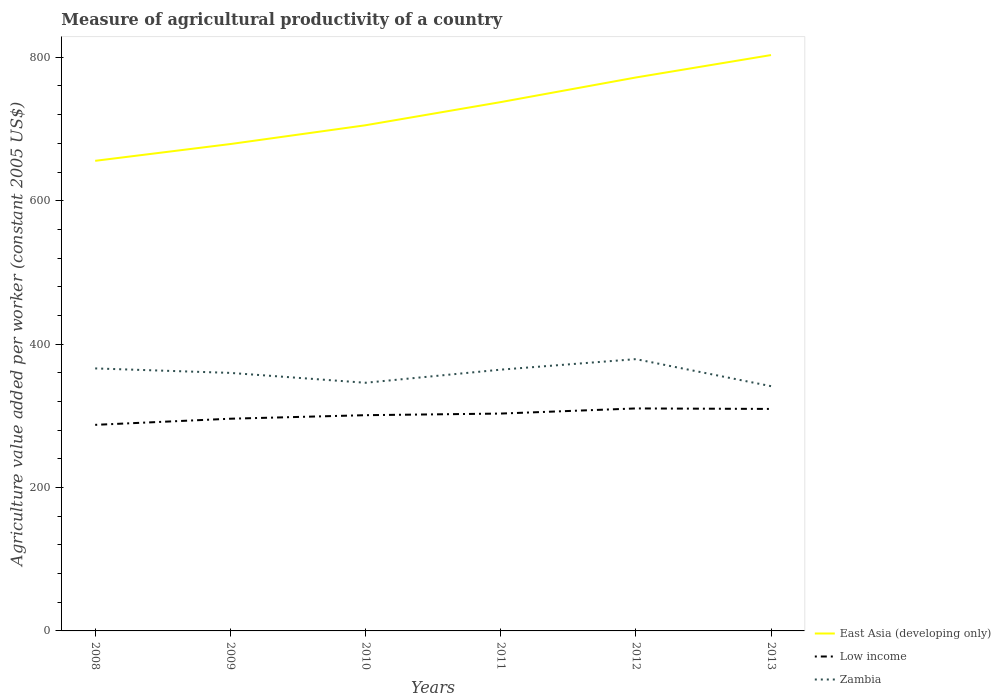How many different coloured lines are there?
Your answer should be very brief. 3. Across all years, what is the maximum measure of agricultural productivity in Low income?
Provide a short and direct response. 287.4. What is the total measure of agricultural productivity in East Asia (developing only) in the graph?
Your response must be concise. -92.83. What is the difference between the highest and the second highest measure of agricultural productivity in Low income?
Give a very brief answer. 22.89. Is the measure of agricultural productivity in Low income strictly greater than the measure of agricultural productivity in East Asia (developing only) over the years?
Provide a short and direct response. Yes. How many lines are there?
Keep it short and to the point. 3. Does the graph contain grids?
Provide a short and direct response. No. What is the title of the graph?
Ensure brevity in your answer.  Measure of agricultural productivity of a country. Does "North America" appear as one of the legend labels in the graph?
Provide a short and direct response. No. What is the label or title of the Y-axis?
Make the answer very short. Agriculture value added per worker (constant 2005 US$). What is the Agriculture value added per worker (constant 2005 US$) of East Asia (developing only) in 2008?
Your answer should be compact. 655.62. What is the Agriculture value added per worker (constant 2005 US$) of Low income in 2008?
Offer a terse response. 287.4. What is the Agriculture value added per worker (constant 2005 US$) of Zambia in 2008?
Give a very brief answer. 366.1. What is the Agriculture value added per worker (constant 2005 US$) in East Asia (developing only) in 2009?
Give a very brief answer. 679.02. What is the Agriculture value added per worker (constant 2005 US$) in Low income in 2009?
Offer a terse response. 295.95. What is the Agriculture value added per worker (constant 2005 US$) in Zambia in 2009?
Offer a terse response. 359.85. What is the Agriculture value added per worker (constant 2005 US$) of East Asia (developing only) in 2010?
Offer a very short reply. 705.23. What is the Agriculture value added per worker (constant 2005 US$) in Low income in 2010?
Make the answer very short. 300.88. What is the Agriculture value added per worker (constant 2005 US$) in Zambia in 2010?
Your answer should be very brief. 346.09. What is the Agriculture value added per worker (constant 2005 US$) of East Asia (developing only) in 2011?
Ensure brevity in your answer.  737.51. What is the Agriculture value added per worker (constant 2005 US$) of Low income in 2011?
Make the answer very short. 303.13. What is the Agriculture value added per worker (constant 2005 US$) in Zambia in 2011?
Your answer should be very brief. 364.38. What is the Agriculture value added per worker (constant 2005 US$) in East Asia (developing only) in 2012?
Ensure brevity in your answer.  771.85. What is the Agriculture value added per worker (constant 2005 US$) in Low income in 2012?
Your answer should be very brief. 310.29. What is the Agriculture value added per worker (constant 2005 US$) in Zambia in 2012?
Your response must be concise. 379.05. What is the Agriculture value added per worker (constant 2005 US$) in East Asia (developing only) in 2013?
Offer a terse response. 803.12. What is the Agriculture value added per worker (constant 2005 US$) of Low income in 2013?
Your answer should be very brief. 309.6. What is the Agriculture value added per worker (constant 2005 US$) of Zambia in 2013?
Your answer should be very brief. 341.34. Across all years, what is the maximum Agriculture value added per worker (constant 2005 US$) in East Asia (developing only)?
Your answer should be compact. 803.12. Across all years, what is the maximum Agriculture value added per worker (constant 2005 US$) of Low income?
Your answer should be very brief. 310.29. Across all years, what is the maximum Agriculture value added per worker (constant 2005 US$) of Zambia?
Your answer should be compact. 379.05. Across all years, what is the minimum Agriculture value added per worker (constant 2005 US$) in East Asia (developing only)?
Make the answer very short. 655.62. Across all years, what is the minimum Agriculture value added per worker (constant 2005 US$) of Low income?
Give a very brief answer. 287.4. Across all years, what is the minimum Agriculture value added per worker (constant 2005 US$) in Zambia?
Give a very brief answer. 341.34. What is the total Agriculture value added per worker (constant 2005 US$) of East Asia (developing only) in the graph?
Your response must be concise. 4352.35. What is the total Agriculture value added per worker (constant 2005 US$) of Low income in the graph?
Keep it short and to the point. 1807.24. What is the total Agriculture value added per worker (constant 2005 US$) of Zambia in the graph?
Provide a short and direct response. 2156.81. What is the difference between the Agriculture value added per worker (constant 2005 US$) of East Asia (developing only) in 2008 and that in 2009?
Give a very brief answer. -23.4. What is the difference between the Agriculture value added per worker (constant 2005 US$) of Low income in 2008 and that in 2009?
Your answer should be compact. -8.55. What is the difference between the Agriculture value added per worker (constant 2005 US$) of Zambia in 2008 and that in 2009?
Offer a terse response. 6.26. What is the difference between the Agriculture value added per worker (constant 2005 US$) in East Asia (developing only) in 2008 and that in 2010?
Provide a succinct answer. -49.61. What is the difference between the Agriculture value added per worker (constant 2005 US$) of Low income in 2008 and that in 2010?
Your answer should be compact. -13.48. What is the difference between the Agriculture value added per worker (constant 2005 US$) in Zambia in 2008 and that in 2010?
Give a very brief answer. 20.01. What is the difference between the Agriculture value added per worker (constant 2005 US$) of East Asia (developing only) in 2008 and that in 2011?
Make the answer very short. -81.89. What is the difference between the Agriculture value added per worker (constant 2005 US$) of Low income in 2008 and that in 2011?
Give a very brief answer. -15.74. What is the difference between the Agriculture value added per worker (constant 2005 US$) of Zambia in 2008 and that in 2011?
Offer a very short reply. 1.72. What is the difference between the Agriculture value added per worker (constant 2005 US$) of East Asia (developing only) in 2008 and that in 2012?
Your response must be concise. -116.23. What is the difference between the Agriculture value added per worker (constant 2005 US$) in Low income in 2008 and that in 2012?
Give a very brief answer. -22.89. What is the difference between the Agriculture value added per worker (constant 2005 US$) of Zambia in 2008 and that in 2012?
Keep it short and to the point. -12.95. What is the difference between the Agriculture value added per worker (constant 2005 US$) of East Asia (developing only) in 2008 and that in 2013?
Your answer should be compact. -147.5. What is the difference between the Agriculture value added per worker (constant 2005 US$) in Low income in 2008 and that in 2013?
Your answer should be very brief. -22.2. What is the difference between the Agriculture value added per worker (constant 2005 US$) of Zambia in 2008 and that in 2013?
Provide a short and direct response. 24.76. What is the difference between the Agriculture value added per worker (constant 2005 US$) of East Asia (developing only) in 2009 and that in 2010?
Your response must be concise. -26.21. What is the difference between the Agriculture value added per worker (constant 2005 US$) in Low income in 2009 and that in 2010?
Make the answer very short. -4.93. What is the difference between the Agriculture value added per worker (constant 2005 US$) in Zambia in 2009 and that in 2010?
Keep it short and to the point. 13.75. What is the difference between the Agriculture value added per worker (constant 2005 US$) of East Asia (developing only) in 2009 and that in 2011?
Provide a succinct answer. -58.49. What is the difference between the Agriculture value added per worker (constant 2005 US$) of Low income in 2009 and that in 2011?
Offer a very short reply. -7.18. What is the difference between the Agriculture value added per worker (constant 2005 US$) in Zambia in 2009 and that in 2011?
Your answer should be compact. -4.53. What is the difference between the Agriculture value added per worker (constant 2005 US$) of East Asia (developing only) in 2009 and that in 2012?
Your answer should be very brief. -92.83. What is the difference between the Agriculture value added per worker (constant 2005 US$) of Low income in 2009 and that in 2012?
Offer a terse response. -14.34. What is the difference between the Agriculture value added per worker (constant 2005 US$) of Zambia in 2009 and that in 2012?
Provide a short and direct response. -19.21. What is the difference between the Agriculture value added per worker (constant 2005 US$) in East Asia (developing only) in 2009 and that in 2013?
Ensure brevity in your answer.  -124.1. What is the difference between the Agriculture value added per worker (constant 2005 US$) of Low income in 2009 and that in 2013?
Make the answer very short. -13.65. What is the difference between the Agriculture value added per worker (constant 2005 US$) in Zambia in 2009 and that in 2013?
Provide a short and direct response. 18.51. What is the difference between the Agriculture value added per worker (constant 2005 US$) in East Asia (developing only) in 2010 and that in 2011?
Offer a very short reply. -32.28. What is the difference between the Agriculture value added per worker (constant 2005 US$) of Low income in 2010 and that in 2011?
Provide a short and direct response. -2.26. What is the difference between the Agriculture value added per worker (constant 2005 US$) of Zambia in 2010 and that in 2011?
Your response must be concise. -18.29. What is the difference between the Agriculture value added per worker (constant 2005 US$) of East Asia (developing only) in 2010 and that in 2012?
Offer a very short reply. -66.62. What is the difference between the Agriculture value added per worker (constant 2005 US$) of Low income in 2010 and that in 2012?
Keep it short and to the point. -9.41. What is the difference between the Agriculture value added per worker (constant 2005 US$) in Zambia in 2010 and that in 2012?
Your response must be concise. -32.96. What is the difference between the Agriculture value added per worker (constant 2005 US$) of East Asia (developing only) in 2010 and that in 2013?
Provide a succinct answer. -97.89. What is the difference between the Agriculture value added per worker (constant 2005 US$) of Low income in 2010 and that in 2013?
Your response must be concise. -8.72. What is the difference between the Agriculture value added per worker (constant 2005 US$) in Zambia in 2010 and that in 2013?
Keep it short and to the point. 4.75. What is the difference between the Agriculture value added per worker (constant 2005 US$) in East Asia (developing only) in 2011 and that in 2012?
Make the answer very short. -34.34. What is the difference between the Agriculture value added per worker (constant 2005 US$) of Low income in 2011 and that in 2012?
Offer a terse response. -7.16. What is the difference between the Agriculture value added per worker (constant 2005 US$) in Zambia in 2011 and that in 2012?
Your response must be concise. -14.67. What is the difference between the Agriculture value added per worker (constant 2005 US$) of East Asia (developing only) in 2011 and that in 2013?
Provide a succinct answer. -65.61. What is the difference between the Agriculture value added per worker (constant 2005 US$) in Low income in 2011 and that in 2013?
Provide a succinct answer. -6.46. What is the difference between the Agriculture value added per worker (constant 2005 US$) in Zambia in 2011 and that in 2013?
Keep it short and to the point. 23.04. What is the difference between the Agriculture value added per worker (constant 2005 US$) in East Asia (developing only) in 2012 and that in 2013?
Keep it short and to the point. -31.27. What is the difference between the Agriculture value added per worker (constant 2005 US$) of Low income in 2012 and that in 2013?
Give a very brief answer. 0.69. What is the difference between the Agriculture value added per worker (constant 2005 US$) in Zambia in 2012 and that in 2013?
Give a very brief answer. 37.71. What is the difference between the Agriculture value added per worker (constant 2005 US$) of East Asia (developing only) in 2008 and the Agriculture value added per worker (constant 2005 US$) of Low income in 2009?
Your response must be concise. 359.67. What is the difference between the Agriculture value added per worker (constant 2005 US$) of East Asia (developing only) in 2008 and the Agriculture value added per worker (constant 2005 US$) of Zambia in 2009?
Offer a terse response. 295.77. What is the difference between the Agriculture value added per worker (constant 2005 US$) in Low income in 2008 and the Agriculture value added per worker (constant 2005 US$) in Zambia in 2009?
Your answer should be very brief. -72.45. What is the difference between the Agriculture value added per worker (constant 2005 US$) of East Asia (developing only) in 2008 and the Agriculture value added per worker (constant 2005 US$) of Low income in 2010?
Your answer should be very brief. 354.74. What is the difference between the Agriculture value added per worker (constant 2005 US$) in East Asia (developing only) in 2008 and the Agriculture value added per worker (constant 2005 US$) in Zambia in 2010?
Give a very brief answer. 309.53. What is the difference between the Agriculture value added per worker (constant 2005 US$) in Low income in 2008 and the Agriculture value added per worker (constant 2005 US$) in Zambia in 2010?
Ensure brevity in your answer.  -58.69. What is the difference between the Agriculture value added per worker (constant 2005 US$) of East Asia (developing only) in 2008 and the Agriculture value added per worker (constant 2005 US$) of Low income in 2011?
Make the answer very short. 352.49. What is the difference between the Agriculture value added per worker (constant 2005 US$) of East Asia (developing only) in 2008 and the Agriculture value added per worker (constant 2005 US$) of Zambia in 2011?
Offer a very short reply. 291.24. What is the difference between the Agriculture value added per worker (constant 2005 US$) in Low income in 2008 and the Agriculture value added per worker (constant 2005 US$) in Zambia in 2011?
Provide a short and direct response. -76.98. What is the difference between the Agriculture value added per worker (constant 2005 US$) in East Asia (developing only) in 2008 and the Agriculture value added per worker (constant 2005 US$) in Low income in 2012?
Your response must be concise. 345.33. What is the difference between the Agriculture value added per worker (constant 2005 US$) of East Asia (developing only) in 2008 and the Agriculture value added per worker (constant 2005 US$) of Zambia in 2012?
Offer a very short reply. 276.57. What is the difference between the Agriculture value added per worker (constant 2005 US$) in Low income in 2008 and the Agriculture value added per worker (constant 2005 US$) in Zambia in 2012?
Your answer should be very brief. -91.65. What is the difference between the Agriculture value added per worker (constant 2005 US$) of East Asia (developing only) in 2008 and the Agriculture value added per worker (constant 2005 US$) of Low income in 2013?
Your answer should be very brief. 346.02. What is the difference between the Agriculture value added per worker (constant 2005 US$) in East Asia (developing only) in 2008 and the Agriculture value added per worker (constant 2005 US$) in Zambia in 2013?
Provide a succinct answer. 314.28. What is the difference between the Agriculture value added per worker (constant 2005 US$) in Low income in 2008 and the Agriculture value added per worker (constant 2005 US$) in Zambia in 2013?
Provide a short and direct response. -53.94. What is the difference between the Agriculture value added per worker (constant 2005 US$) in East Asia (developing only) in 2009 and the Agriculture value added per worker (constant 2005 US$) in Low income in 2010?
Offer a very short reply. 378.15. What is the difference between the Agriculture value added per worker (constant 2005 US$) in East Asia (developing only) in 2009 and the Agriculture value added per worker (constant 2005 US$) in Zambia in 2010?
Offer a very short reply. 332.93. What is the difference between the Agriculture value added per worker (constant 2005 US$) in Low income in 2009 and the Agriculture value added per worker (constant 2005 US$) in Zambia in 2010?
Provide a short and direct response. -50.14. What is the difference between the Agriculture value added per worker (constant 2005 US$) in East Asia (developing only) in 2009 and the Agriculture value added per worker (constant 2005 US$) in Low income in 2011?
Your answer should be very brief. 375.89. What is the difference between the Agriculture value added per worker (constant 2005 US$) of East Asia (developing only) in 2009 and the Agriculture value added per worker (constant 2005 US$) of Zambia in 2011?
Your answer should be very brief. 314.64. What is the difference between the Agriculture value added per worker (constant 2005 US$) in Low income in 2009 and the Agriculture value added per worker (constant 2005 US$) in Zambia in 2011?
Provide a succinct answer. -68.43. What is the difference between the Agriculture value added per worker (constant 2005 US$) in East Asia (developing only) in 2009 and the Agriculture value added per worker (constant 2005 US$) in Low income in 2012?
Keep it short and to the point. 368.73. What is the difference between the Agriculture value added per worker (constant 2005 US$) in East Asia (developing only) in 2009 and the Agriculture value added per worker (constant 2005 US$) in Zambia in 2012?
Provide a succinct answer. 299.97. What is the difference between the Agriculture value added per worker (constant 2005 US$) of Low income in 2009 and the Agriculture value added per worker (constant 2005 US$) of Zambia in 2012?
Provide a short and direct response. -83.1. What is the difference between the Agriculture value added per worker (constant 2005 US$) in East Asia (developing only) in 2009 and the Agriculture value added per worker (constant 2005 US$) in Low income in 2013?
Provide a succinct answer. 369.42. What is the difference between the Agriculture value added per worker (constant 2005 US$) in East Asia (developing only) in 2009 and the Agriculture value added per worker (constant 2005 US$) in Zambia in 2013?
Your answer should be compact. 337.68. What is the difference between the Agriculture value added per worker (constant 2005 US$) in Low income in 2009 and the Agriculture value added per worker (constant 2005 US$) in Zambia in 2013?
Provide a short and direct response. -45.39. What is the difference between the Agriculture value added per worker (constant 2005 US$) of East Asia (developing only) in 2010 and the Agriculture value added per worker (constant 2005 US$) of Low income in 2011?
Give a very brief answer. 402.1. What is the difference between the Agriculture value added per worker (constant 2005 US$) in East Asia (developing only) in 2010 and the Agriculture value added per worker (constant 2005 US$) in Zambia in 2011?
Provide a short and direct response. 340.85. What is the difference between the Agriculture value added per worker (constant 2005 US$) in Low income in 2010 and the Agriculture value added per worker (constant 2005 US$) in Zambia in 2011?
Your answer should be very brief. -63.5. What is the difference between the Agriculture value added per worker (constant 2005 US$) in East Asia (developing only) in 2010 and the Agriculture value added per worker (constant 2005 US$) in Low income in 2012?
Your answer should be compact. 394.94. What is the difference between the Agriculture value added per worker (constant 2005 US$) of East Asia (developing only) in 2010 and the Agriculture value added per worker (constant 2005 US$) of Zambia in 2012?
Offer a very short reply. 326.18. What is the difference between the Agriculture value added per worker (constant 2005 US$) in Low income in 2010 and the Agriculture value added per worker (constant 2005 US$) in Zambia in 2012?
Your response must be concise. -78.18. What is the difference between the Agriculture value added per worker (constant 2005 US$) in East Asia (developing only) in 2010 and the Agriculture value added per worker (constant 2005 US$) in Low income in 2013?
Ensure brevity in your answer.  395.63. What is the difference between the Agriculture value added per worker (constant 2005 US$) of East Asia (developing only) in 2010 and the Agriculture value added per worker (constant 2005 US$) of Zambia in 2013?
Your response must be concise. 363.89. What is the difference between the Agriculture value added per worker (constant 2005 US$) of Low income in 2010 and the Agriculture value added per worker (constant 2005 US$) of Zambia in 2013?
Your answer should be compact. -40.46. What is the difference between the Agriculture value added per worker (constant 2005 US$) in East Asia (developing only) in 2011 and the Agriculture value added per worker (constant 2005 US$) in Low income in 2012?
Give a very brief answer. 427.22. What is the difference between the Agriculture value added per worker (constant 2005 US$) of East Asia (developing only) in 2011 and the Agriculture value added per worker (constant 2005 US$) of Zambia in 2012?
Offer a very short reply. 358.46. What is the difference between the Agriculture value added per worker (constant 2005 US$) in Low income in 2011 and the Agriculture value added per worker (constant 2005 US$) in Zambia in 2012?
Make the answer very short. -75.92. What is the difference between the Agriculture value added per worker (constant 2005 US$) in East Asia (developing only) in 2011 and the Agriculture value added per worker (constant 2005 US$) in Low income in 2013?
Provide a short and direct response. 427.91. What is the difference between the Agriculture value added per worker (constant 2005 US$) of East Asia (developing only) in 2011 and the Agriculture value added per worker (constant 2005 US$) of Zambia in 2013?
Keep it short and to the point. 396.17. What is the difference between the Agriculture value added per worker (constant 2005 US$) in Low income in 2011 and the Agriculture value added per worker (constant 2005 US$) in Zambia in 2013?
Give a very brief answer. -38.2. What is the difference between the Agriculture value added per worker (constant 2005 US$) in East Asia (developing only) in 2012 and the Agriculture value added per worker (constant 2005 US$) in Low income in 2013?
Your answer should be very brief. 462.25. What is the difference between the Agriculture value added per worker (constant 2005 US$) in East Asia (developing only) in 2012 and the Agriculture value added per worker (constant 2005 US$) in Zambia in 2013?
Offer a very short reply. 430.51. What is the difference between the Agriculture value added per worker (constant 2005 US$) in Low income in 2012 and the Agriculture value added per worker (constant 2005 US$) in Zambia in 2013?
Offer a terse response. -31.05. What is the average Agriculture value added per worker (constant 2005 US$) of East Asia (developing only) per year?
Give a very brief answer. 725.39. What is the average Agriculture value added per worker (constant 2005 US$) of Low income per year?
Your response must be concise. 301.21. What is the average Agriculture value added per worker (constant 2005 US$) of Zambia per year?
Your response must be concise. 359.47. In the year 2008, what is the difference between the Agriculture value added per worker (constant 2005 US$) of East Asia (developing only) and Agriculture value added per worker (constant 2005 US$) of Low income?
Make the answer very short. 368.22. In the year 2008, what is the difference between the Agriculture value added per worker (constant 2005 US$) in East Asia (developing only) and Agriculture value added per worker (constant 2005 US$) in Zambia?
Ensure brevity in your answer.  289.52. In the year 2008, what is the difference between the Agriculture value added per worker (constant 2005 US$) in Low income and Agriculture value added per worker (constant 2005 US$) in Zambia?
Provide a succinct answer. -78.7. In the year 2009, what is the difference between the Agriculture value added per worker (constant 2005 US$) of East Asia (developing only) and Agriculture value added per worker (constant 2005 US$) of Low income?
Your response must be concise. 383.07. In the year 2009, what is the difference between the Agriculture value added per worker (constant 2005 US$) in East Asia (developing only) and Agriculture value added per worker (constant 2005 US$) in Zambia?
Keep it short and to the point. 319.18. In the year 2009, what is the difference between the Agriculture value added per worker (constant 2005 US$) of Low income and Agriculture value added per worker (constant 2005 US$) of Zambia?
Keep it short and to the point. -63.89. In the year 2010, what is the difference between the Agriculture value added per worker (constant 2005 US$) in East Asia (developing only) and Agriculture value added per worker (constant 2005 US$) in Low income?
Provide a short and direct response. 404.35. In the year 2010, what is the difference between the Agriculture value added per worker (constant 2005 US$) of East Asia (developing only) and Agriculture value added per worker (constant 2005 US$) of Zambia?
Offer a terse response. 359.14. In the year 2010, what is the difference between the Agriculture value added per worker (constant 2005 US$) of Low income and Agriculture value added per worker (constant 2005 US$) of Zambia?
Offer a terse response. -45.22. In the year 2011, what is the difference between the Agriculture value added per worker (constant 2005 US$) in East Asia (developing only) and Agriculture value added per worker (constant 2005 US$) in Low income?
Offer a terse response. 434.38. In the year 2011, what is the difference between the Agriculture value added per worker (constant 2005 US$) in East Asia (developing only) and Agriculture value added per worker (constant 2005 US$) in Zambia?
Keep it short and to the point. 373.13. In the year 2011, what is the difference between the Agriculture value added per worker (constant 2005 US$) in Low income and Agriculture value added per worker (constant 2005 US$) in Zambia?
Keep it short and to the point. -61.24. In the year 2012, what is the difference between the Agriculture value added per worker (constant 2005 US$) of East Asia (developing only) and Agriculture value added per worker (constant 2005 US$) of Low income?
Give a very brief answer. 461.56. In the year 2012, what is the difference between the Agriculture value added per worker (constant 2005 US$) of East Asia (developing only) and Agriculture value added per worker (constant 2005 US$) of Zambia?
Keep it short and to the point. 392.8. In the year 2012, what is the difference between the Agriculture value added per worker (constant 2005 US$) of Low income and Agriculture value added per worker (constant 2005 US$) of Zambia?
Keep it short and to the point. -68.76. In the year 2013, what is the difference between the Agriculture value added per worker (constant 2005 US$) of East Asia (developing only) and Agriculture value added per worker (constant 2005 US$) of Low income?
Provide a short and direct response. 493.52. In the year 2013, what is the difference between the Agriculture value added per worker (constant 2005 US$) in East Asia (developing only) and Agriculture value added per worker (constant 2005 US$) in Zambia?
Your response must be concise. 461.78. In the year 2013, what is the difference between the Agriculture value added per worker (constant 2005 US$) in Low income and Agriculture value added per worker (constant 2005 US$) in Zambia?
Make the answer very short. -31.74. What is the ratio of the Agriculture value added per worker (constant 2005 US$) in East Asia (developing only) in 2008 to that in 2009?
Offer a very short reply. 0.97. What is the ratio of the Agriculture value added per worker (constant 2005 US$) in Low income in 2008 to that in 2009?
Keep it short and to the point. 0.97. What is the ratio of the Agriculture value added per worker (constant 2005 US$) of Zambia in 2008 to that in 2009?
Offer a terse response. 1.02. What is the ratio of the Agriculture value added per worker (constant 2005 US$) in East Asia (developing only) in 2008 to that in 2010?
Ensure brevity in your answer.  0.93. What is the ratio of the Agriculture value added per worker (constant 2005 US$) in Low income in 2008 to that in 2010?
Provide a short and direct response. 0.96. What is the ratio of the Agriculture value added per worker (constant 2005 US$) in Zambia in 2008 to that in 2010?
Ensure brevity in your answer.  1.06. What is the ratio of the Agriculture value added per worker (constant 2005 US$) of East Asia (developing only) in 2008 to that in 2011?
Offer a terse response. 0.89. What is the ratio of the Agriculture value added per worker (constant 2005 US$) in Low income in 2008 to that in 2011?
Your answer should be very brief. 0.95. What is the ratio of the Agriculture value added per worker (constant 2005 US$) of East Asia (developing only) in 2008 to that in 2012?
Keep it short and to the point. 0.85. What is the ratio of the Agriculture value added per worker (constant 2005 US$) of Low income in 2008 to that in 2012?
Make the answer very short. 0.93. What is the ratio of the Agriculture value added per worker (constant 2005 US$) of Zambia in 2008 to that in 2012?
Make the answer very short. 0.97. What is the ratio of the Agriculture value added per worker (constant 2005 US$) in East Asia (developing only) in 2008 to that in 2013?
Your answer should be compact. 0.82. What is the ratio of the Agriculture value added per worker (constant 2005 US$) in Low income in 2008 to that in 2013?
Your answer should be very brief. 0.93. What is the ratio of the Agriculture value added per worker (constant 2005 US$) in Zambia in 2008 to that in 2013?
Your answer should be compact. 1.07. What is the ratio of the Agriculture value added per worker (constant 2005 US$) in East Asia (developing only) in 2009 to that in 2010?
Give a very brief answer. 0.96. What is the ratio of the Agriculture value added per worker (constant 2005 US$) of Low income in 2009 to that in 2010?
Your response must be concise. 0.98. What is the ratio of the Agriculture value added per worker (constant 2005 US$) of Zambia in 2009 to that in 2010?
Provide a succinct answer. 1.04. What is the ratio of the Agriculture value added per worker (constant 2005 US$) of East Asia (developing only) in 2009 to that in 2011?
Your answer should be compact. 0.92. What is the ratio of the Agriculture value added per worker (constant 2005 US$) in Low income in 2009 to that in 2011?
Offer a terse response. 0.98. What is the ratio of the Agriculture value added per worker (constant 2005 US$) in Zambia in 2009 to that in 2011?
Offer a terse response. 0.99. What is the ratio of the Agriculture value added per worker (constant 2005 US$) of East Asia (developing only) in 2009 to that in 2012?
Ensure brevity in your answer.  0.88. What is the ratio of the Agriculture value added per worker (constant 2005 US$) in Low income in 2009 to that in 2012?
Offer a very short reply. 0.95. What is the ratio of the Agriculture value added per worker (constant 2005 US$) of Zambia in 2009 to that in 2012?
Keep it short and to the point. 0.95. What is the ratio of the Agriculture value added per worker (constant 2005 US$) in East Asia (developing only) in 2009 to that in 2013?
Provide a short and direct response. 0.85. What is the ratio of the Agriculture value added per worker (constant 2005 US$) in Low income in 2009 to that in 2013?
Your answer should be compact. 0.96. What is the ratio of the Agriculture value added per worker (constant 2005 US$) in Zambia in 2009 to that in 2013?
Your answer should be very brief. 1.05. What is the ratio of the Agriculture value added per worker (constant 2005 US$) of East Asia (developing only) in 2010 to that in 2011?
Give a very brief answer. 0.96. What is the ratio of the Agriculture value added per worker (constant 2005 US$) in Low income in 2010 to that in 2011?
Make the answer very short. 0.99. What is the ratio of the Agriculture value added per worker (constant 2005 US$) of Zambia in 2010 to that in 2011?
Give a very brief answer. 0.95. What is the ratio of the Agriculture value added per worker (constant 2005 US$) of East Asia (developing only) in 2010 to that in 2012?
Offer a terse response. 0.91. What is the ratio of the Agriculture value added per worker (constant 2005 US$) of Low income in 2010 to that in 2012?
Provide a succinct answer. 0.97. What is the ratio of the Agriculture value added per worker (constant 2005 US$) in Zambia in 2010 to that in 2012?
Your answer should be compact. 0.91. What is the ratio of the Agriculture value added per worker (constant 2005 US$) in East Asia (developing only) in 2010 to that in 2013?
Keep it short and to the point. 0.88. What is the ratio of the Agriculture value added per worker (constant 2005 US$) of Low income in 2010 to that in 2013?
Offer a terse response. 0.97. What is the ratio of the Agriculture value added per worker (constant 2005 US$) of Zambia in 2010 to that in 2013?
Provide a succinct answer. 1.01. What is the ratio of the Agriculture value added per worker (constant 2005 US$) of East Asia (developing only) in 2011 to that in 2012?
Make the answer very short. 0.96. What is the ratio of the Agriculture value added per worker (constant 2005 US$) in Low income in 2011 to that in 2012?
Make the answer very short. 0.98. What is the ratio of the Agriculture value added per worker (constant 2005 US$) in Zambia in 2011 to that in 2012?
Give a very brief answer. 0.96. What is the ratio of the Agriculture value added per worker (constant 2005 US$) of East Asia (developing only) in 2011 to that in 2013?
Your response must be concise. 0.92. What is the ratio of the Agriculture value added per worker (constant 2005 US$) in Low income in 2011 to that in 2013?
Your response must be concise. 0.98. What is the ratio of the Agriculture value added per worker (constant 2005 US$) of Zambia in 2011 to that in 2013?
Your answer should be compact. 1.07. What is the ratio of the Agriculture value added per worker (constant 2005 US$) of East Asia (developing only) in 2012 to that in 2013?
Your response must be concise. 0.96. What is the ratio of the Agriculture value added per worker (constant 2005 US$) in Zambia in 2012 to that in 2013?
Make the answer very short. 1.11. What is the difference between the highest and the second highest Agriculture value added per worker (constant 2005 US$) in East Asia (developing only)?
Your answer should be compact. 31.27. What is the difference between the highest and the second highest Agriculture value added per worker (constant 2005 US$) in Low income?
Give a very brief answer. 0.69. What is the difference between the highest and the second highest Agriculture value added per worker (constant 2005 US$) in Zambia?
Keep it short and to the point. 12.95. What is the difference between the highest and the lowest Agriculture value added per worker (constant 2005 US$) of East Asia (developing only)?
Provide a short and direct response. 147.5. What is the difference between the highest and the lowest Agriculture value added per worker (constant 2005 US$) of Low income?
Offer a very short reply. 22.89. What is the difference between the highest and the lowest Agriculture value added per worker (constant 2005 US$) of Zambia?
Keep it short and to the point. 37.71. 